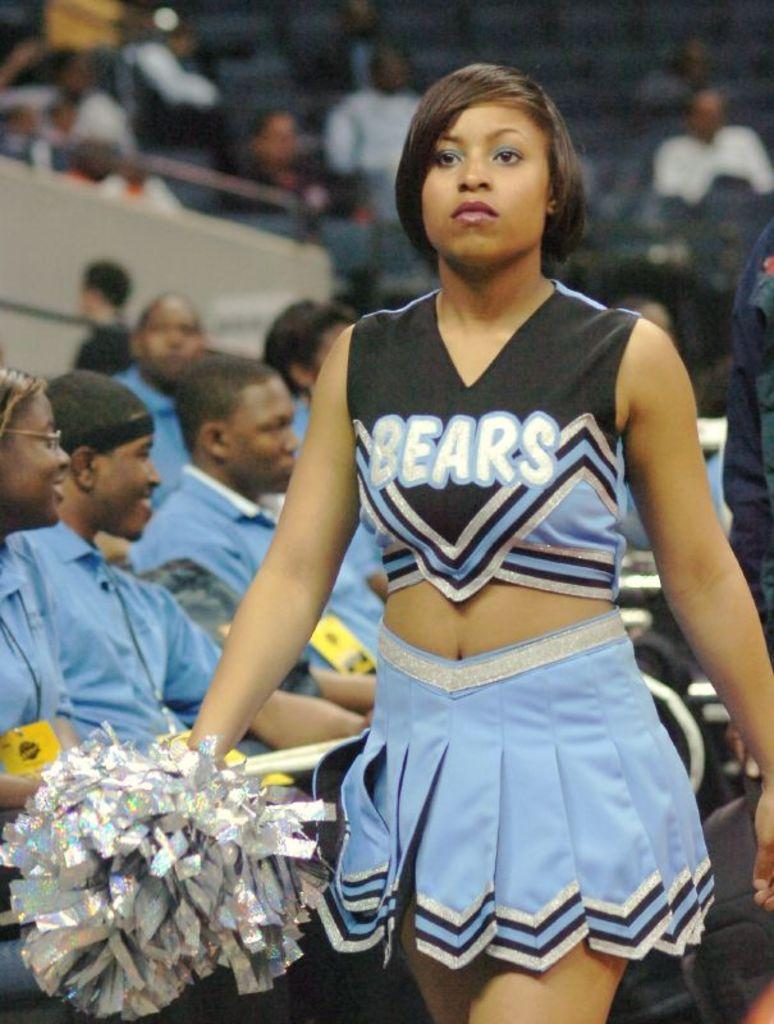<image>
Render a clear and concise summary of the photo. a lady that is wearing a bears jersey in an auditorium 